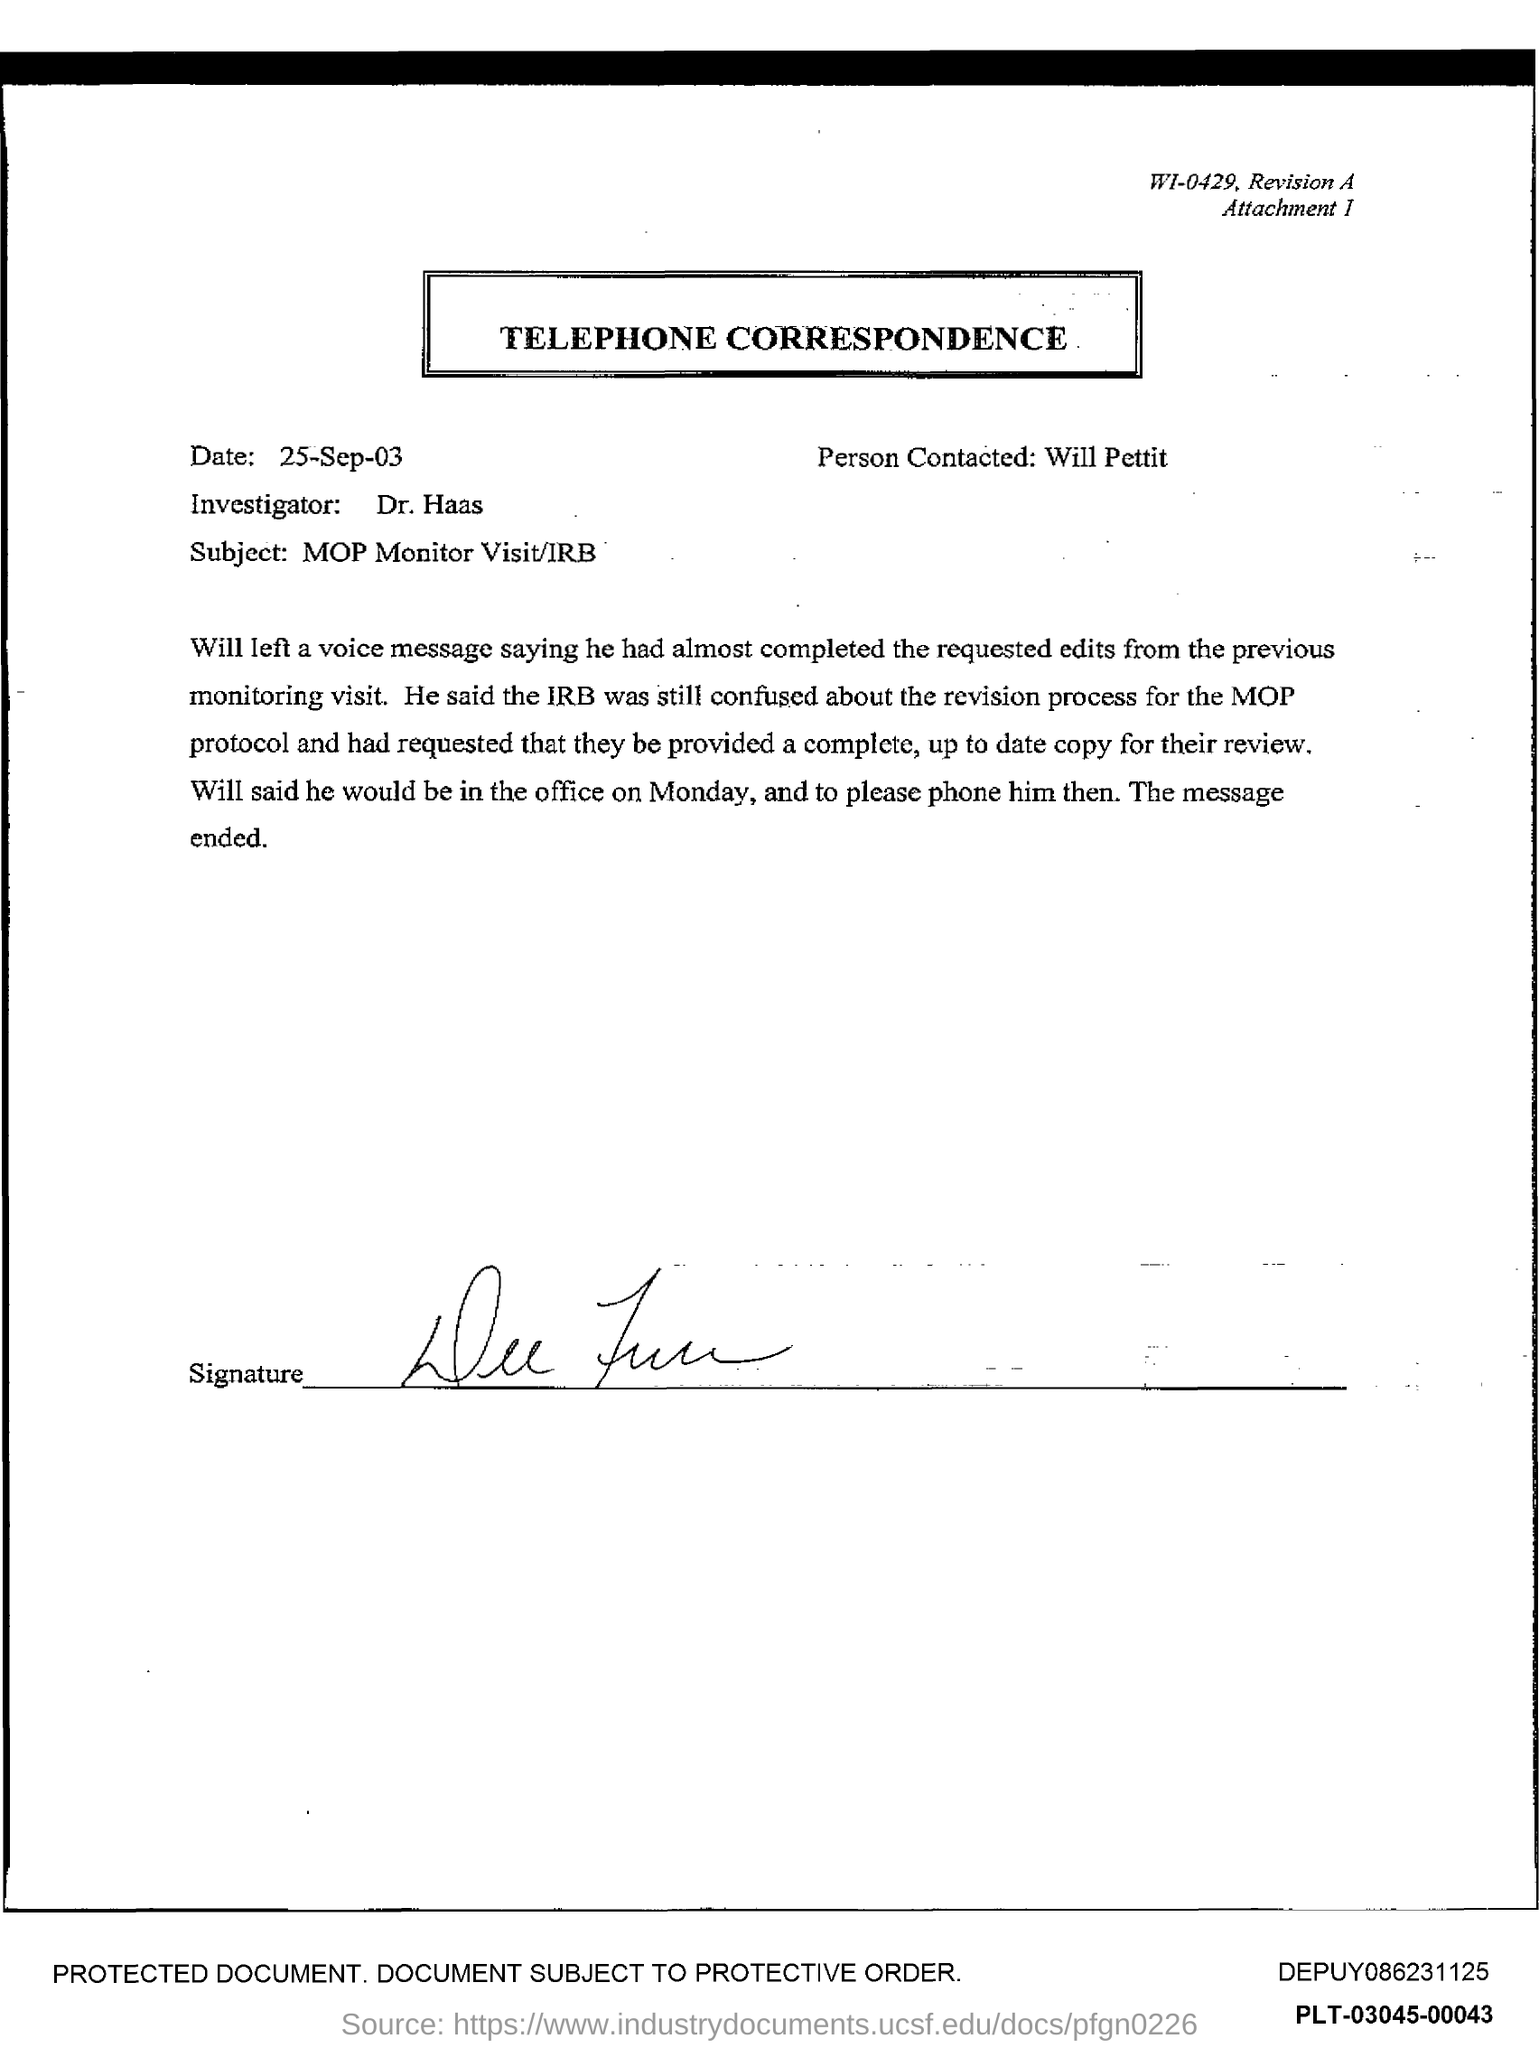Give some essential details in this illustration. The person contacted is named Will Pettit. The date at the top of the page is September 25, 2003. 